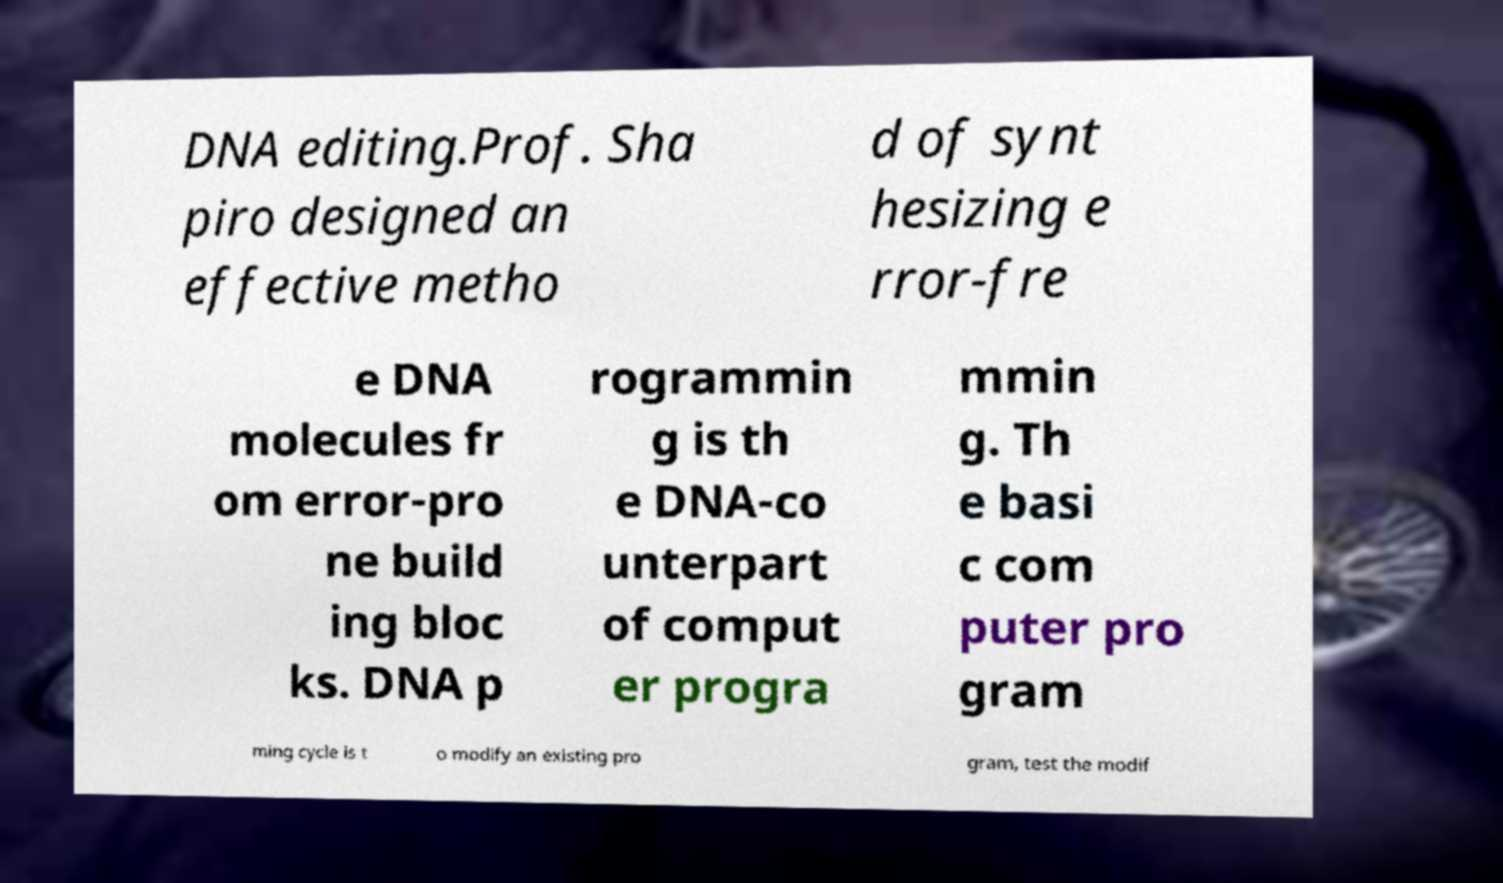Please read and relay the text visible in this image. What does it say? DNA editing.Prof. Sha piro designed an effective metho d of synt hesizing e rror-fre e DNA molecules fr om error-pro ne build ing bloc ks. DNA p rogrammin g is th e DNA-co unterpart of comput er progra mmin g. Th e basi c com puter pro gram ming cycle is t o modify an existing pro gram, test the modif 